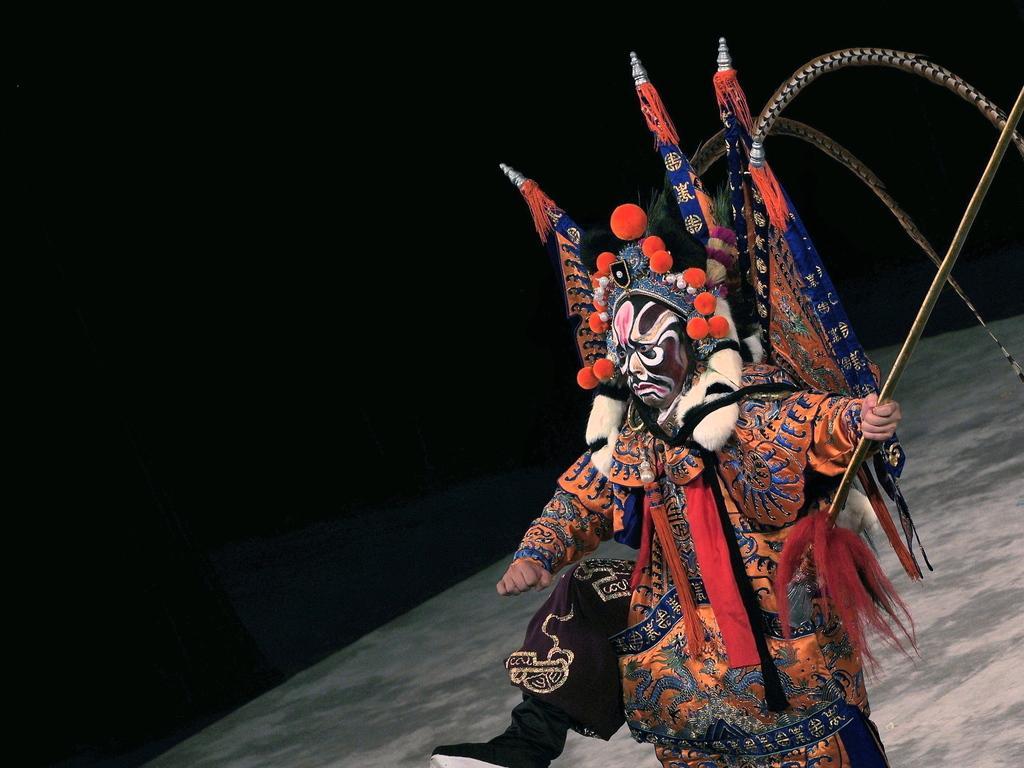How would you summarize this image in a sentence or two? In this image there is a person truncated towards the bottom of the image, the person is holding an object, there are objects truncated towards the right of the image, the background of the image is dark. 